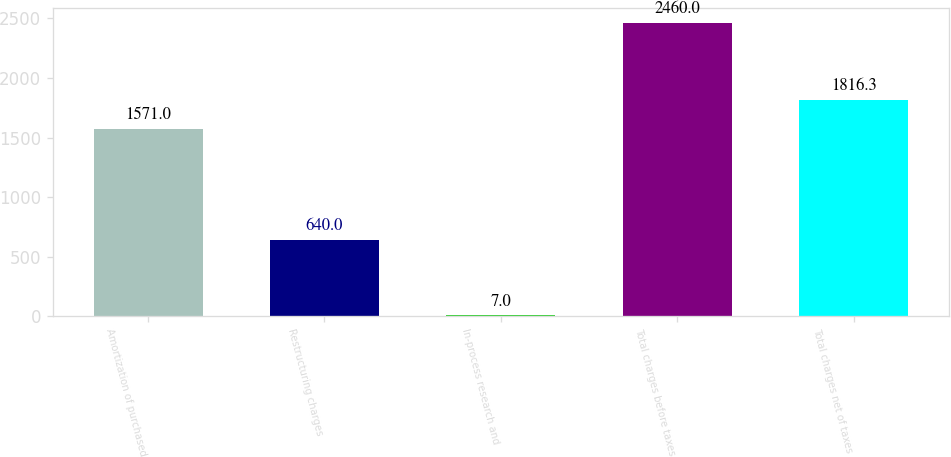Convert chart. <chart><loc_0><loc_0><loc_500><loc_500><bar_chart><fcel>Amortization of purchased<fcel>Restructuring charges<fcel>In-process research and<fcel>Total charges before taxes<fcel>Total charges net of taxes<nl><fcel>1571<fcel>640<fcel>7<fcel>2460<fcel>1816.3<nl></chart> 